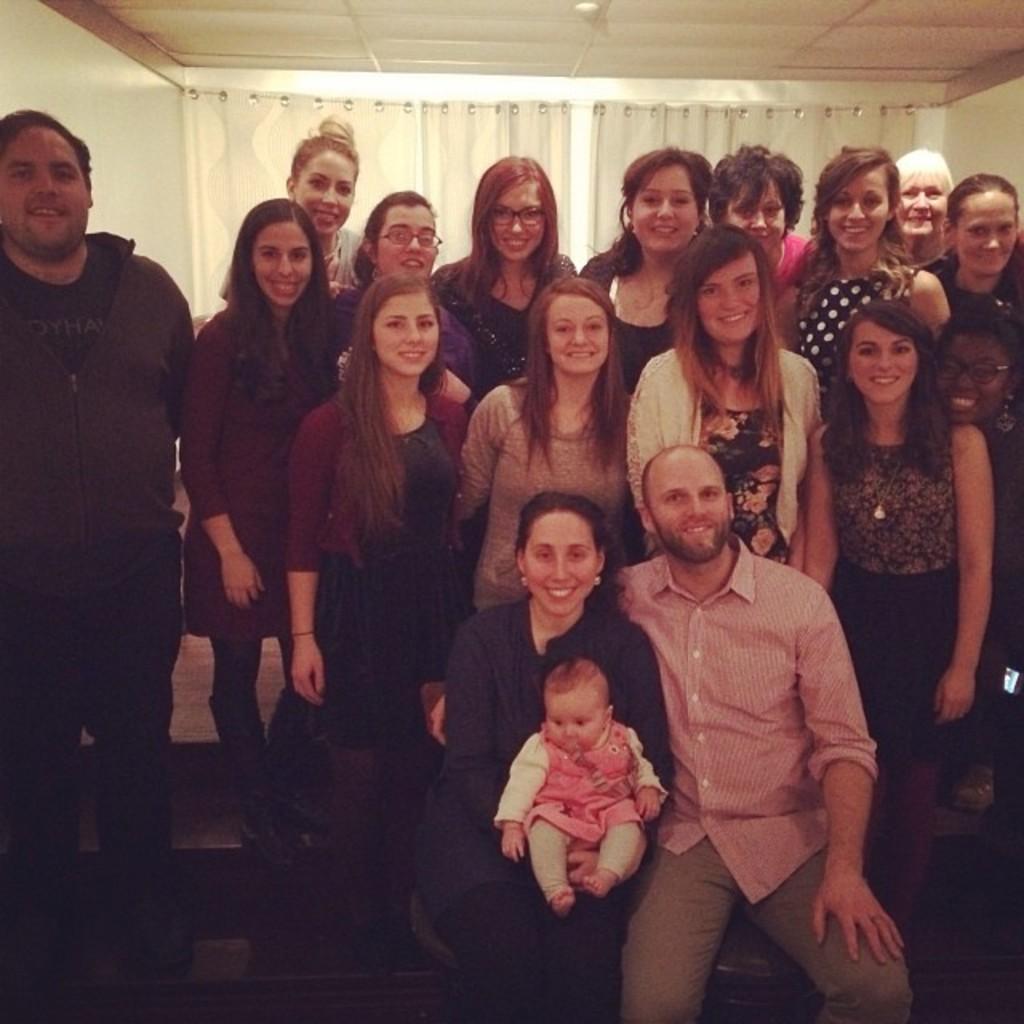Please provide a concise description of this image. This picture describes about group of people, few are seated and few are standing, and they are all smiling, in the background we can see curtains. 